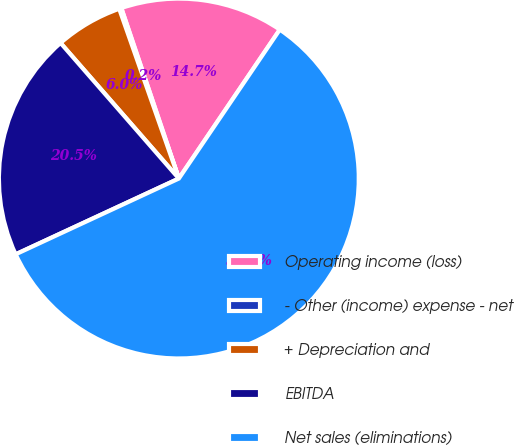Convert chart to OTSL. <chart><loc_0><loc_0><loc_500><loc_500><pie_chart><fcel>Operating income (loss)<fcel>- Other (income) expense - net<fcel>+ Depreciation and<fcel>EBITDA<fcel>Net sales (eliminations)<nl><fcel>14.66%<fcel>0.2%<fcel>6.04%<fcel>20.5%<fcel>58.6%<nl></chart> 